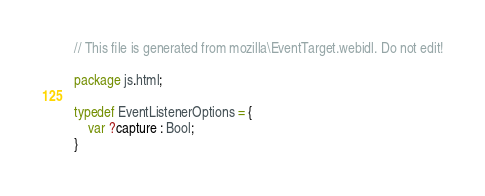Convert code to text. <code><loc_0><loc_0><loc_500><loc_500><_Haxe_>
// This file is generated from mozilla\EventTarget.webidl. Do not edit!

package js.html;

typedef EventListenerOptions = {
	var ?capture : Bool;
}</code> 